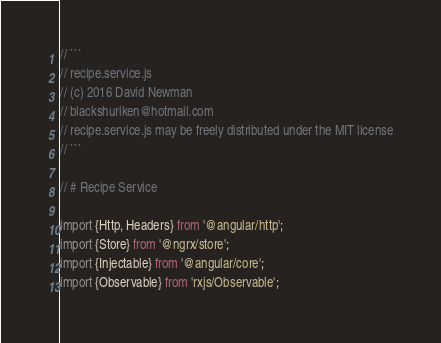<code> <loc_0><loc_0><loc_500><loc_500><_TypeScript_>// ```
// recipe.service.js
// (c) 2016 David Newman
// blackshuriken@hotmail.com
// recipe.service.js may be freely distributed under the MIT license
// ```

// # Recipe Service

import {Http, Headers} from '@angular/http';
import {Store} from '@ngrx/store';
import {Injectable} from '@angular/core';
import {Observable} from 'rxjs/Observable';
</code> 